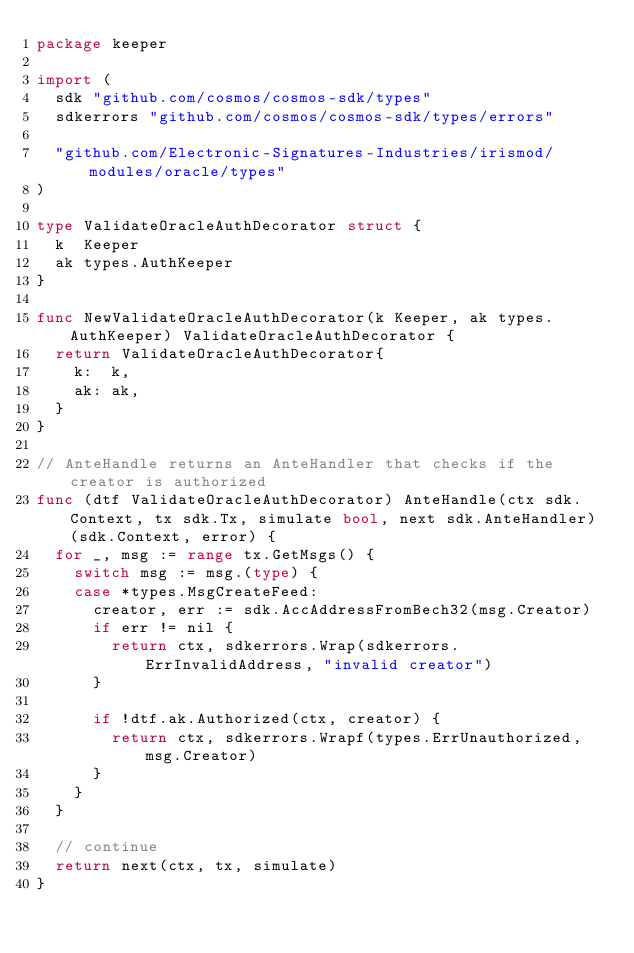Convert code to text. <code><loc_0><loc_0><loc_500><loc_500><_Go_>package keeper

import (
	sdk "github.com/cosmos/cosmos-sdk/types"
	sdkerrors "github.com/cosmos/cosmos-sdk/types/errors"

	"github.com/Electronic-Signatures-Industries/irismod/modules/oracle/types"
)

type ValidateOracleAuthDecorator struct {
	k  Keeper
	ak types.AuthKeeper
}

func NewValidateOracleAuthDecorator(k Keeper, ak types.AuthKeeper) ValidateOracleAuthDecorator {
	return ValidateOracleAuthDecorator{
		k:  k,
		ak: ak,
	}
}

// AnteHandle returns an AnteHandler that checks if the creator is authorized
func (dtf ValidateOracleAuthDecorator) AnteHandle(ctx sdk.Context, tx sdk.Tx, simulate bool, next sdk.AnteHandler) (sdk.Context, error) {
	for _, msg := range tx.GetMsgs() {
		switch msg := msg.(type) {
		case *types.MsgCreateFeed:
			creator, err := sdk.AccAddressFromBech32(msg.Creator)
			if err != nil {
				return ctx, sdkerrors.Wrap(sdkerrors.ErrInvalidAddress, "invalid creator")
			}

			if !dtf.ak.Authorized(ctx, creator) {
				return ctx, sdkerrors.Wrapf(types.ErrUnauthorized, msg.Creator)
			}
		}
	}

	// continue
	return next(ctx, tx, simulate)
}
</code> 